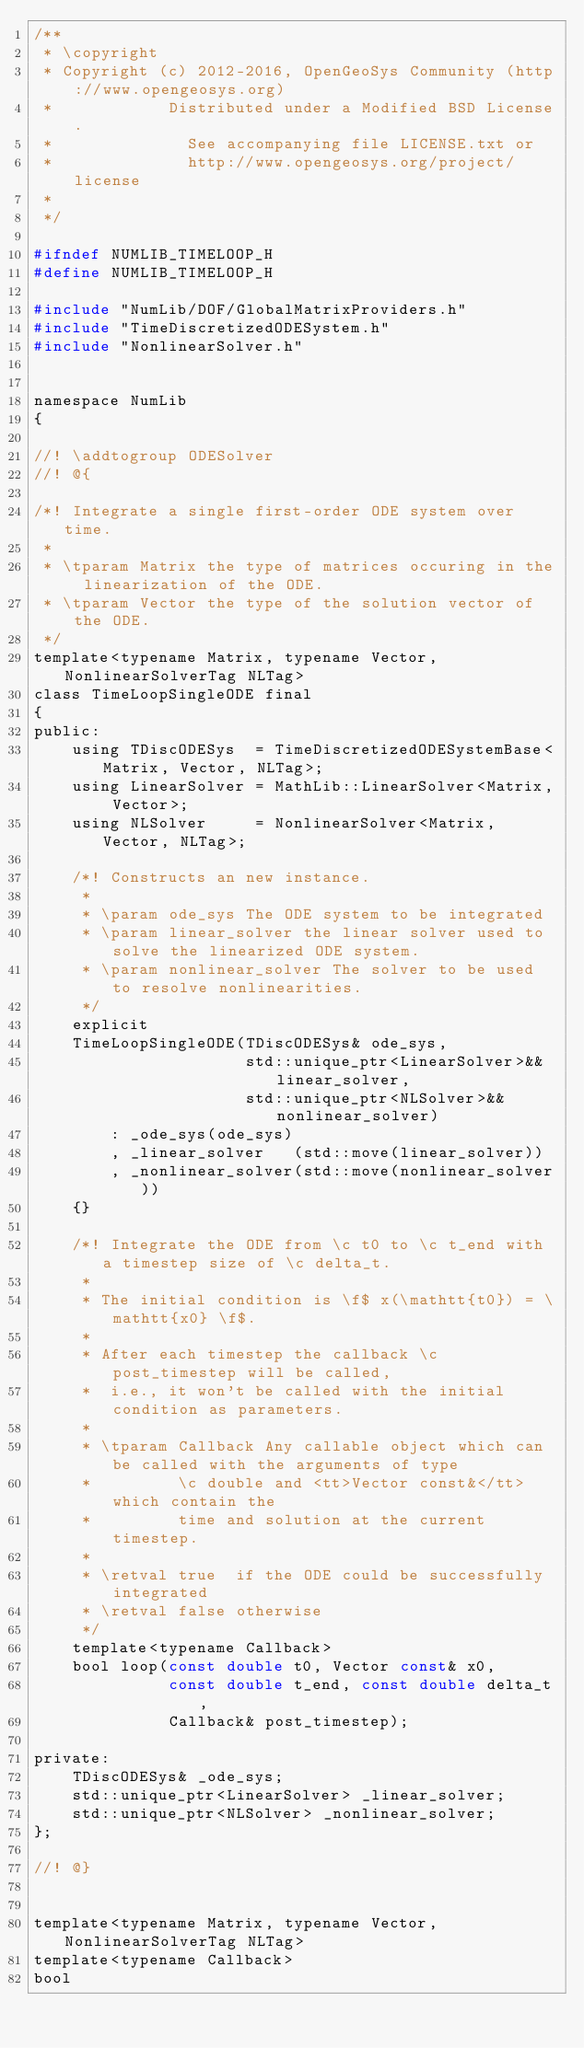<code> <loc_0><loc_0><loc_500><loc_500><_C_>/**
 * \copyright
 * Copyright (c) 2012-2016, OpenGeoSys Community (http://www.opengeosys.org)
 *            Distributed under a Modified BSD License.
 *              See accompanying file LICENSE.txt or
 *              http://www.opengeosys.org/project/license
 *
 */

#ifndef NUMLIB_TIMELOOP_H
#define NUMLIB_TIMELOOP_H

#include "NumLib/DOF/GlobalMatrixProviders.h"
#include "TimeDiscretizedODESystem.h"
#include "NonlinearSolver.h"


namespace NumLib
{

//! \addtogroup ODESolver
//! @{

/*! Integrate a single first-order ODE system over time.
 *
 * \tparam Matrix the type of matrices occuring in the linearization of the ODE.
 * \tparam Vector the type of the solution vector of the ODE.
 */
template<typename Matrix, typename Vector, NonlinearSolverTag NLTag>
class TimeLoopSingleODE final
{
public:
    using TDiscODESys  = TimeDiscretizedODESystemBase<Matrix, Vector, NLTag>;
    using LinearSolver = MathLib::LinearSolver<Matrix, Vector>;
    using NLSolver     = NonlinearSolver<Matrix, Vector, NLTag>;

    /*! Constructs an new instance.
     *
     * \param ode_sys The ODE system to be integrated
     * \param linear_solver the linear solver used to solve the linearized ODE system.
     * \param nonlinear_solver The solver to be used to resolve nonlinearities.
     */
    explicit
    TimeLoopSingleODE(TDiscODESys& ode_sys,
                      std::unique_ptr<LinearSolver>&& linear_solver,
                      std::unique_ptr<NLSolver>&& nonlinear_solver)
        : _ode_sys(ode_sys)
        , _linear_solver   (std::move(linear_solver))
        , _nonlinear_solver(std::move(nonlinear_solver))
    {}

    /*! Integrate the ODE from \c t0 to \c t_end with a timestep size of \c delta_t.
     *
     * The initial condition is \f$ x(\mathtt{t0}) = \mathtt{x0} \f$.
     *
     * After each timestep the callback \c post_timestep will be called,
     *  i.e., it won't be called with the initial condition as parameters.
     *
     * \tparam Callback Any callable object which can be called with the arguments of type
     *         \c double and <tt>Vector const&</tt> which contain the
     *         time and solution at the current timestep.
     *
     * \retval true  if the ODE could be successfully integrated
     * \retval false otherwise
     */
    template<typename Callback>
    bool loop(const double t0, Vector const& x0,
              const double t_end, const double delta_t,
              Callback& post_timestep);

private:
    TDiscODESys& _ode_sys;
    std::unique_ptr<LinearSolver> _linear_solver;
    std::unique_ptr<NLSolver> _nonlinear_solver;
};

//! @}


template<typename Matrix, typename Vector, NonlinearSolverTag NLTag>
template<typename Callback>
bool</code> 